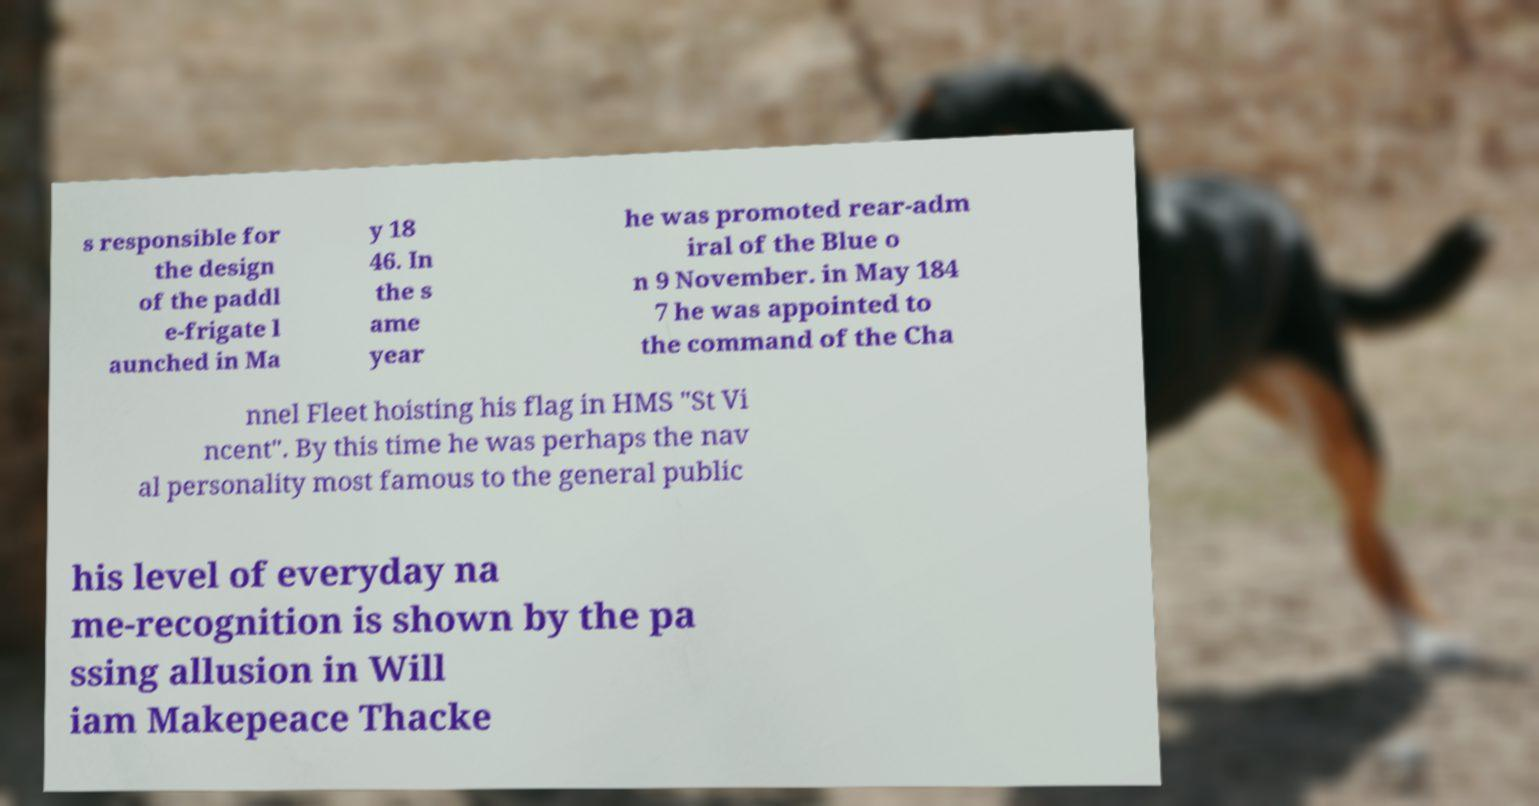Please identify and transcribe the text found in this image. s responsible for the design of the paddl e-frigate l aunched in Ma y 18 46. In the s ame year he was promoted rear-adm iral of the Blue o n 9 November. in May 184 7 he was appointed to the command of the Cha nnel Fleet hoisting his flag in HMS "St Vi ncent". By this time he was perhaps the nav al personality most famous to the general public his level of everyday na me-recognition is shown by the pa ssing allusion in Will iam Makepeace Thacke 